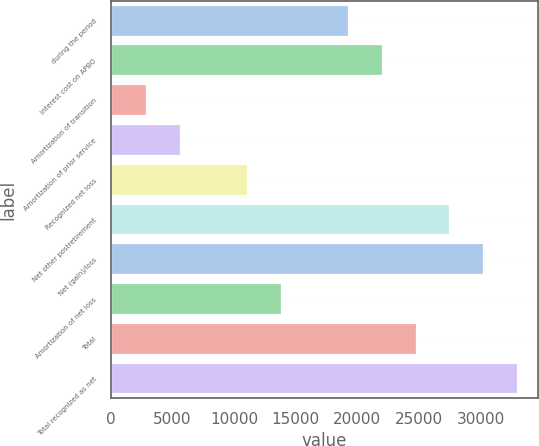Convert chart. <chart><loc_0><loc_0><loc_500><loc_500><bar_chart><fcel>during the period<fcel>Interest cost on APBO<fcel>Amortization of transition<fcel>Amortization of prior service<fcel>Recognized net loss<fcel>Net other postretirement<fcel>Net (gain)/loss<fcel>Amortization of net loss<fcel>Total<fcel>Total recognized as net<nl><fcel>19355.7<fcel>22086.8<fcel>2969.1<fcel>5700.2<fcel>11162.4<fcel>27549<fcel>30280.1<fcel>13893.5<fcel>24817.9<fcel>33011.2<nl></chart> 